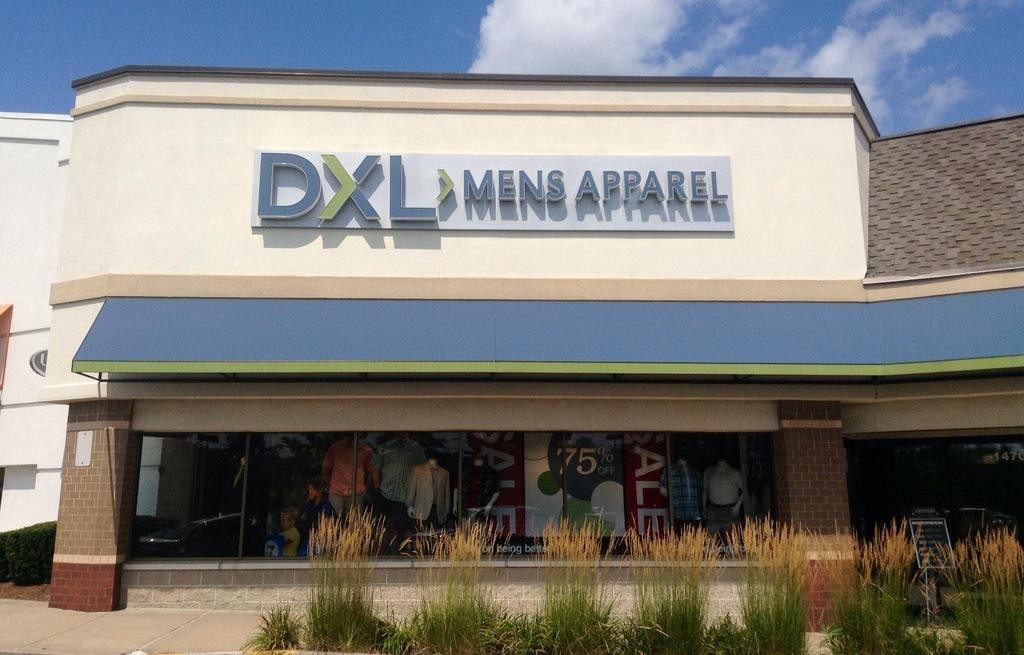What type of structure can be seen in the image? There is a building in the image. What type of vegetation is present in the image? Bushes and shrubs are visible in the image, along with plants. What type of signage is present in the image? Information boards, name boards, and advertisements are visible in the image. What else can be seen in the image? Mannequins are present in the image. What is visible in the background of the image? The sky is visible in the image, with clouds present. What color of paint is being used on the chair in the image? There is no chair present in the image, so it is not possible to determine the color of paint being used. 